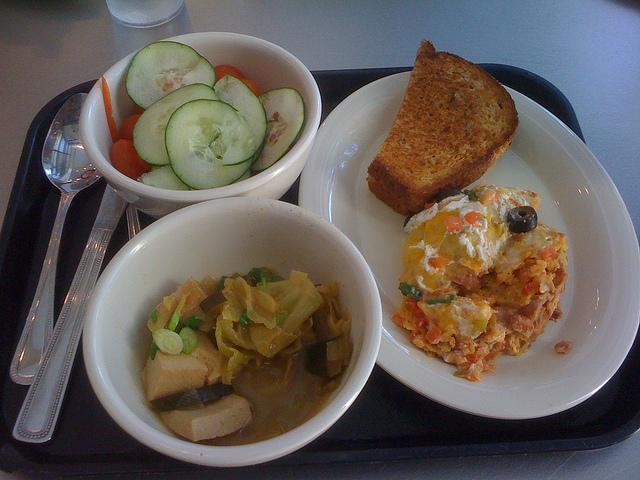How many spoons do you see?
Give a very brief answer. 1. How many bowls are there?
Give a very brief answer. 2. How many type of food is there?
Give a very brief answer. 4. How many foods are uneaten?
Give a very brief answer. 4. How many cargo trucks do you see?
Give a very brief answer. 0. 